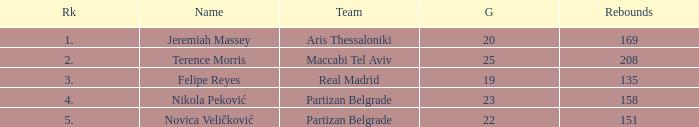I'm looking to parse the entire table for insights. Could you assist me with that? {'header': ['Rk', 'Name', 'Team', 'G', 'Rebounds'], 'rows': [['1.', 'Jeremiah Massey', 'Aris Thessaloniki', '20', '169'], ['2.', 'Terence Morris', 'Maccabi Tel Aviv', '25', '208'], ['3.', 'Felipe Reyes', 'Real Madrid', '19', '135'], ['4.', 'Nikola Peković', 'Partizan Belgrade', '23', '158'], ['5.', 'Novica Veličković', 'Partizan Belgrade', '22', '151']]} How many Games for Terence Morris? 25.0. 